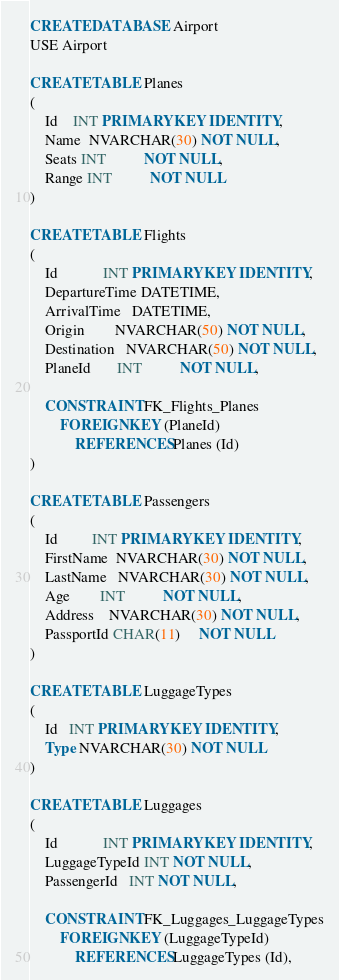<code> <loc_0><loc_0><loc_500><loc_500><_SQL_>CREATE DATABASE Airport
USE Airport

CREATE TABLE Planes
(
    Id    INT PRIMARY KEY IDENTITY,
    Name  NVARCHAR(30) NOT NULL,
    Seats INT          NOT NULL,
    Range INT          NOT NULL
)

CREATE TABLE Flights
(
    Id            INT PRIMARY KEY IDENTITY,
    DepartureTime DATETIME,
    ArrivalTime   DATETIME,
    Origin        NVARCHAR(50) NOT NULL,
    Destination   NVARCHAR(50) NOT NULL,
    PlaneId       INT          NOT NULL,

    CONSTRAINT FK_Flights_Planes
        FOREIGN KEY (PlaneId)
            REFERENCES Planes (Id)
)

CREATE TABLE Passengers
(
    Id         INT PRIMARY KEY IDENTITY,
    FirstName  NVARCHAR(30) NOT NULL,
    LastName   NVARCHAR(30) NOT NULL,
    Age        INT          NOT NULL,
    Address    NVARCHAR(30) NOT NULL,
    PassportId CHAR(11)     NOT NULL
)

CREATE TABLE LuggageTypes
(
    Id   INT PRIMARY KEY IDENTITY,
    Type NVARCHAR(30) NOT NULL
)

CREATE TABLE Luggages
(
    Id            INT PRIMARY KEY IDENTITY,
    LuggageTypeId INT NOT NULL,
    PassengerId   INT NOT NULL,

    CONSTRAINT FK_Luggages_LuggageTypes
        FOREIGN KEY (LuggageTypeId)
            REFERENCES LuggageTypes (Id),
</code> 